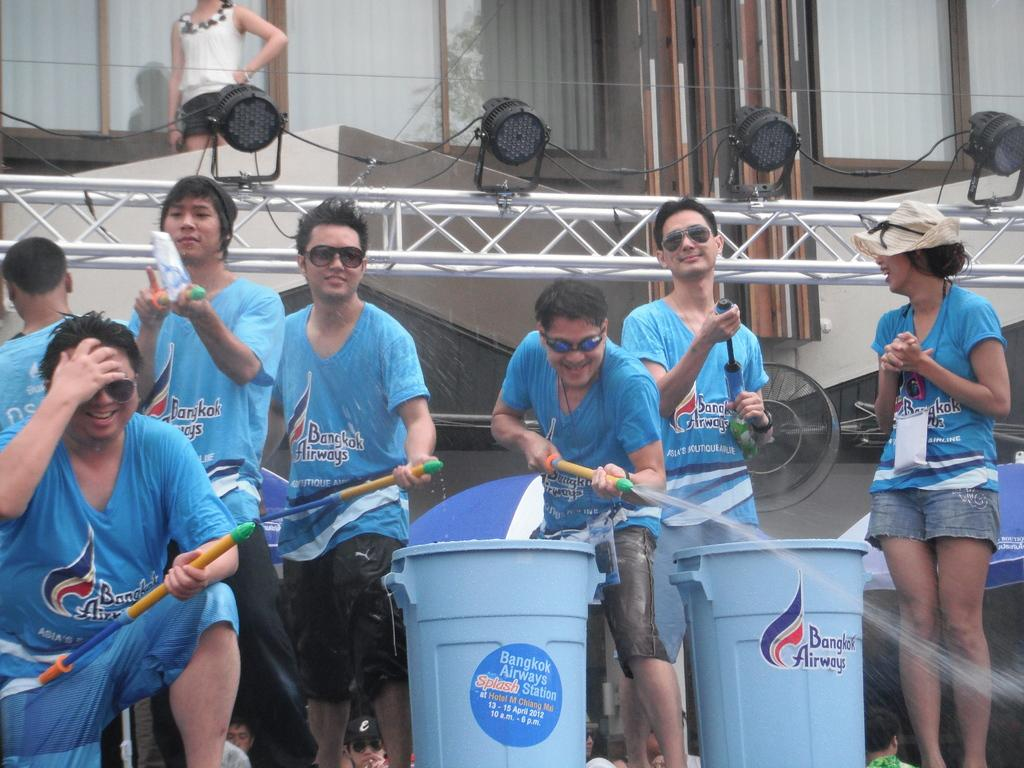<image>
Share a concise interpretation of the image provided. A group of men wearing blue shirts embellished with the words Bangkok Airways sprays water at the crowd 